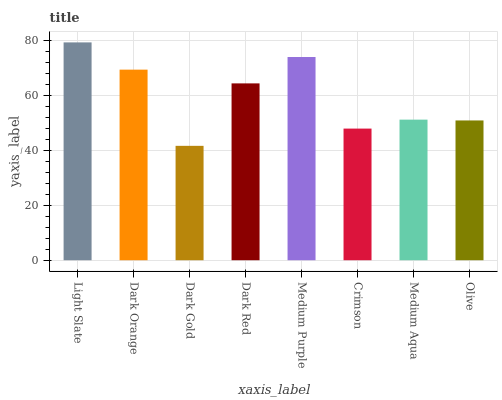Is Dark Orange the minimum?
Answer yes or no. No. Is Dark Orange the maximum?
Answer yes or no. No. Is Light Slate greater than Dark Orange?
Answer yes or no. Yes. Is Dark Orange less than Light Slate?
Answer yes or no. Yes. Is Dark Orange greater than Light Slate?
Answer yes or no. No. Is Light Slate less than Dark Orange?
Answer yes or no. No. Is Dark Red the high median?
Answer yes or no. Yes. Is Medium Aqua the low median?
Answer yes or no. Yes. Is Medium Purple the high median?
Answer yes or no. No. Is Dark Orange the low median?
Answer yes or no. No. 